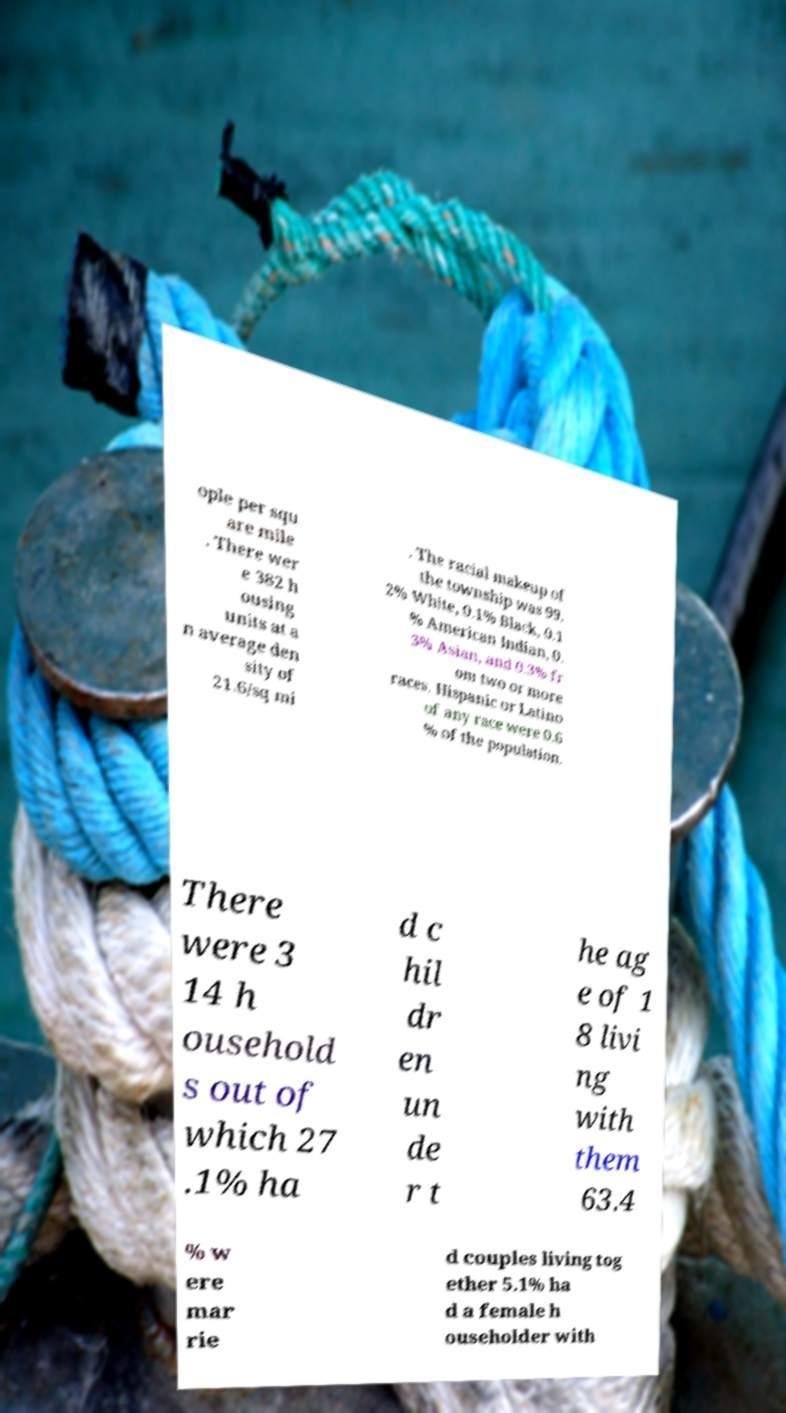Please identify and transcribe the text found in this image. ople per squ are mile . There wer e 382 h ousing units at a n average den sity of 21.6/sq mi . The racial makeup of the township was 99. 2% White, 0.1% Black, 0.1 % American Indian, 0. 3% Asian, and 0.3% fr om two or more races. Hispanic or Latino of any race were 0.6 % of the population. There were 3 14 h ousehold s out of which 27 .1% ha d c hil dr en un de r t he ag e of 1 8 livi ng with them 63.4 % w ere mar rie d couples living tog ether 5.1% ha d a female h ouseholder with 